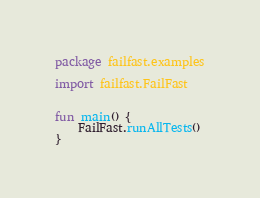Convert code to text. <code><loc_0><loc_0><loc_500><loc_500><_Kotlin_>package failfast.examples

import failfast.FailFast


fun main() {
    FailFast.runAllTests()
}

</code> 